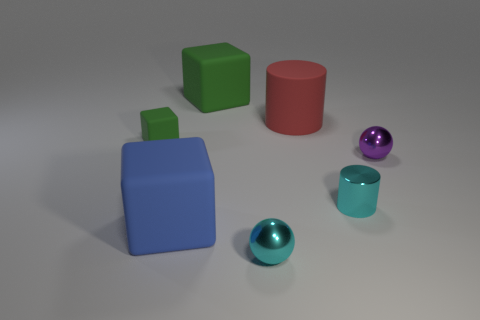Are there any small green metallic spheres?
Ensure brevity in your answer.  No. Does the purple metallic thing have the same size as the blue rubber block that is left of the shiny cylinder?
Your answer should be very brief. No. There is a metallic ball to the right of the red thing; is there a ball that is to the left of it?
Your answer should be compact. Yes. There is a tiny thing that is left of the red object and on the right side of the big blue matte thing; what material is it?
Your answer should be very brief. Metal. There is a big rubber cube in front of the green thing in front of the large cube that is behind the red matte thing; what color is it?
Your response must be concise. Blue. There is a cylinder that is the same size as the purple object; what color is it?
Your response must be concise. Cyan. Is the color of the tiny rubber thing the same as the large rubber cube that is behind the purple object?
Give a very brief answer. Yes. What is the material of the big cube behind the small cyan cylinder on the right side of the blue block?
Make the answer very short. Rubber. How many objects are behind the purple metallic object and in front of the big rubber cylinder?
Give a very brief answer. 1. What number of other things are there of the same size as the rubber cylinder?
Ensure brevity in your answer.  2. 